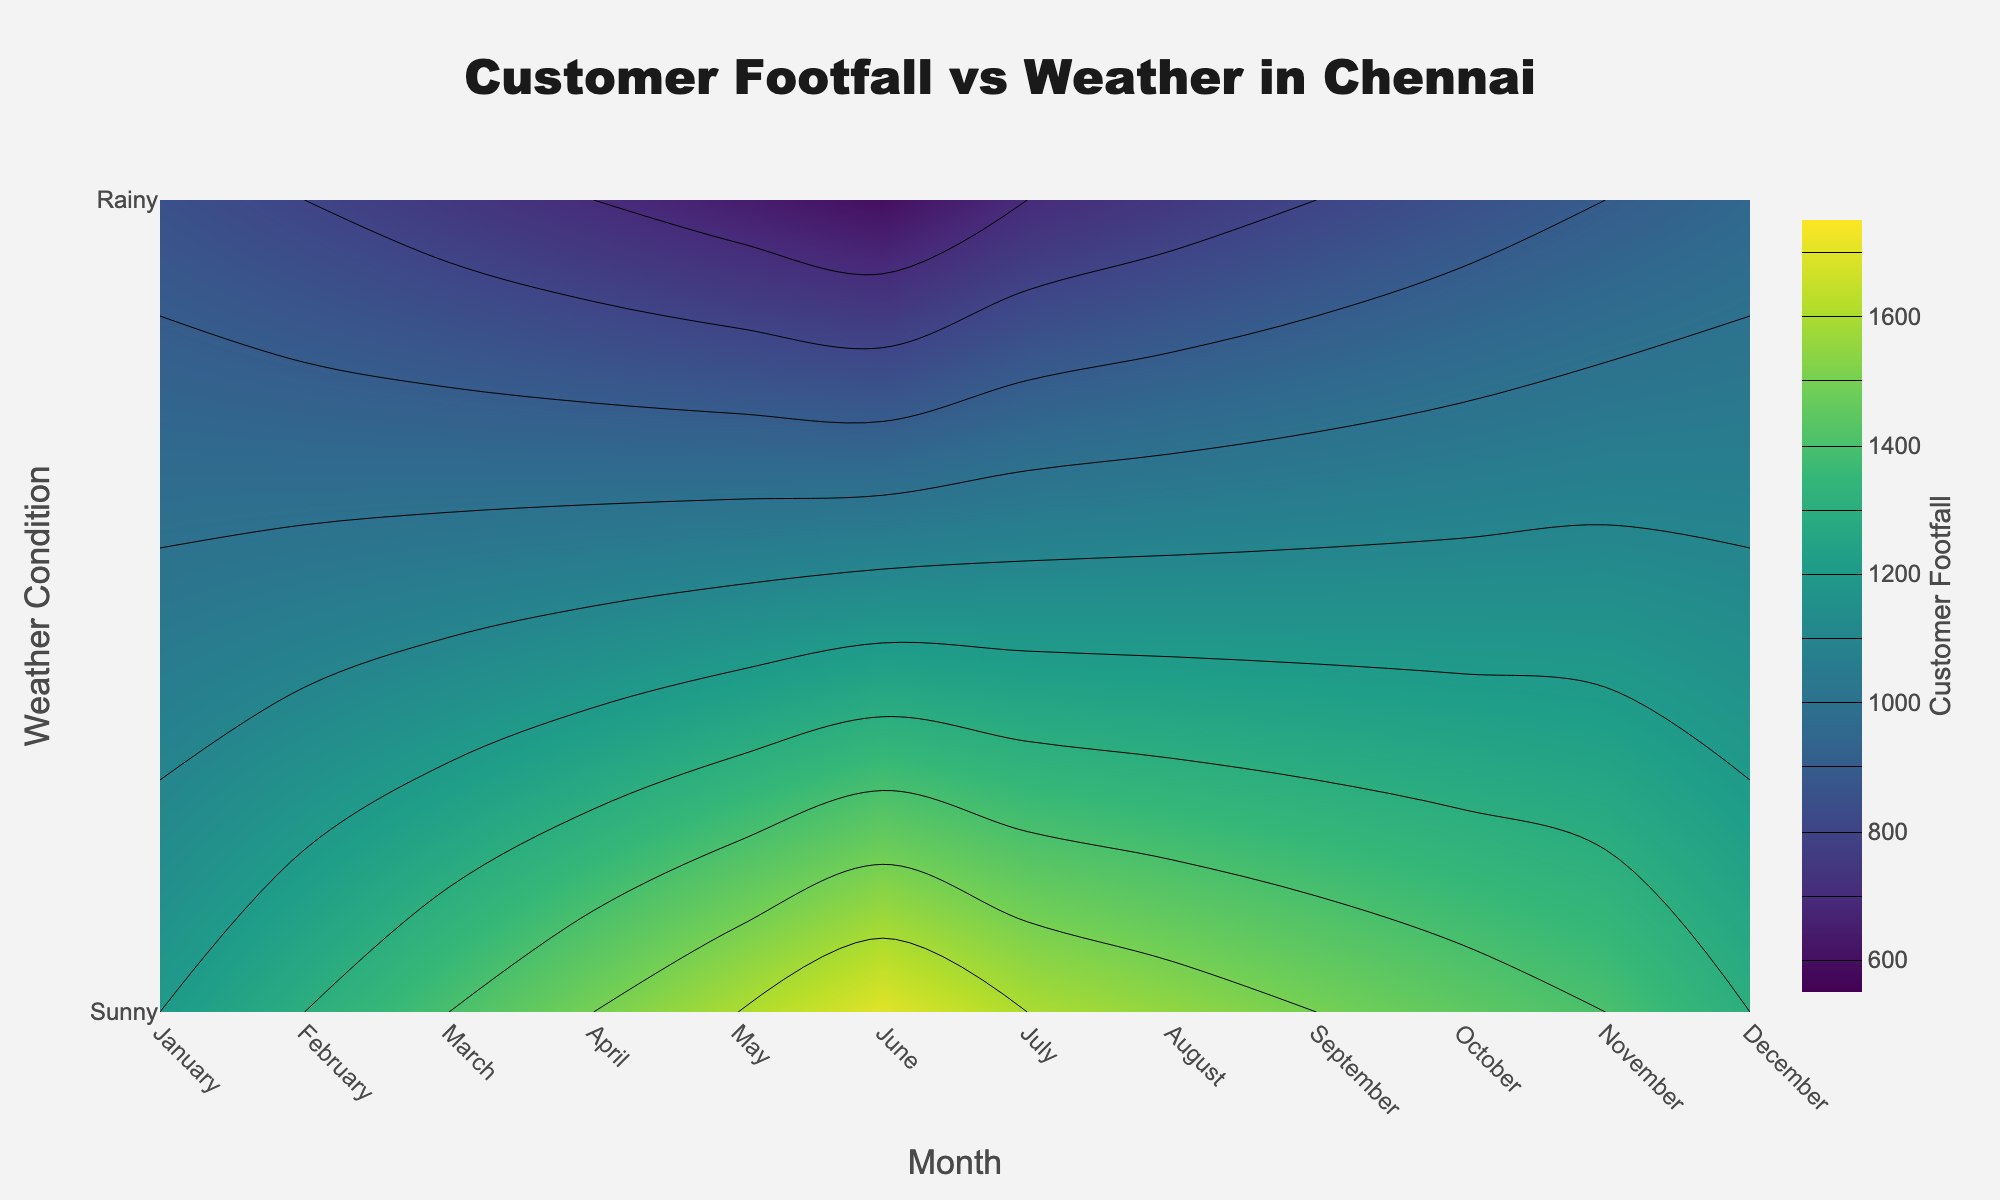What is the title of the plot? The title of the plot is typically located at the top of the figure. It provides a brief description of what the figure is about. In this case, the title is "Customer Footfall vs Weather in Chennai."
Answer: Customer Footfall vs Weather in Chennai Which weather condition generally has higher customer footfall? By examining the contour levels in the plot, it can be observed that the "Sunny" weather condition generally has higher customer footfall values compared to "Rainy" weather. The color gradient typically shows higher values for "Sunny" conditions.
Answer: Sunny During which month does the customer footfall peak for sunny weather? Observing the contour plot, the highest customer footfall under sunny conditions appears around June. This month shows the highest value on the "Sunny" row of the contour plot.
Answer: June What is the approximate customer footfall for rainy weather in December? The color and contour line corresponding to December under "Rainy" conditions can be matched to the color bar on the right. It shows values around 950.
Answer: 950 How does customer footfall change from January to June in sunny weather? Following the contour plot from January to June along the "Sunny" row, the footfall increases steadily from 1200 in January to 1700 in June.
Answer: It increases Compare the customer footfall in April for sunny and rainy weather conditions. Which is higher and by how much? In April, the footfall for "Sunny" weather is 1500 and for "Rainy" weather is 700. The difference can be calculated as 1500 - 700.
Answer: Sunny by 800 What are the weather conditions that have the lowest customer footfall, and during which month(s) do they occur? Looking at the lowest contour levels, "Rainy" weather conditions generally have the lowest customer footfall, which reaches its minimum (600) in June.
Answer: Rainy in June Is there a month where footfall in rainy weather surpasses footfall in sunny weather? Analyzing the plot for each month, generally, "Sunny" always has higher footfall than "Rainy". No month shows rainy weather footfall surpassing sunny weather footfall.
Answer: No During which months is the footfall the same for both sunny and rainy weather conditions? There are no contours indicating that footfall values overlap for both conditions at any specific point, hence they are not the same in any month.
Answer: None 